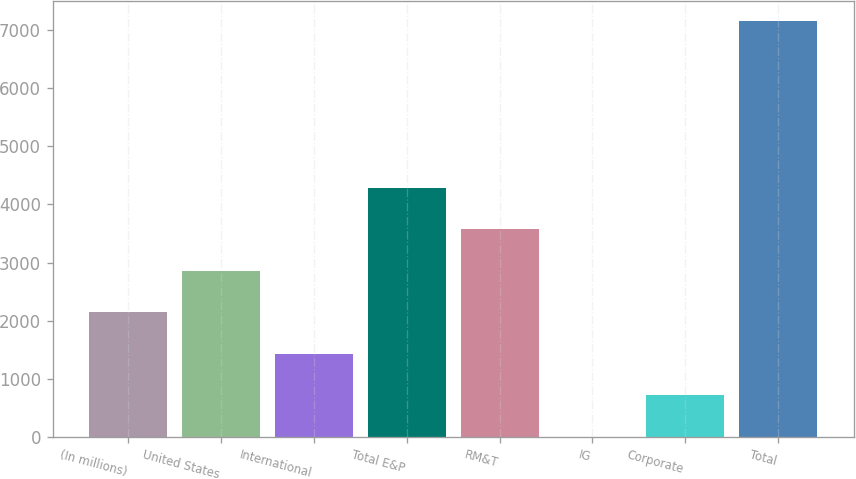<chart> <loc_0><loc_0><loc_500><loc_500><bar_chart><fcel>(In millions)<fcel>United States<fcel>International<fcel>Total E&P<fcel>RM&T<fcel>IG<fcel>Corporate<fcel>Total<nl><fcel>2146.6<fcel>2860.8<fcel>1432.4<fcel>4289.2<fcel>3575<fcel>4<fcel>718.2<fcel>7146<nl></chart> 